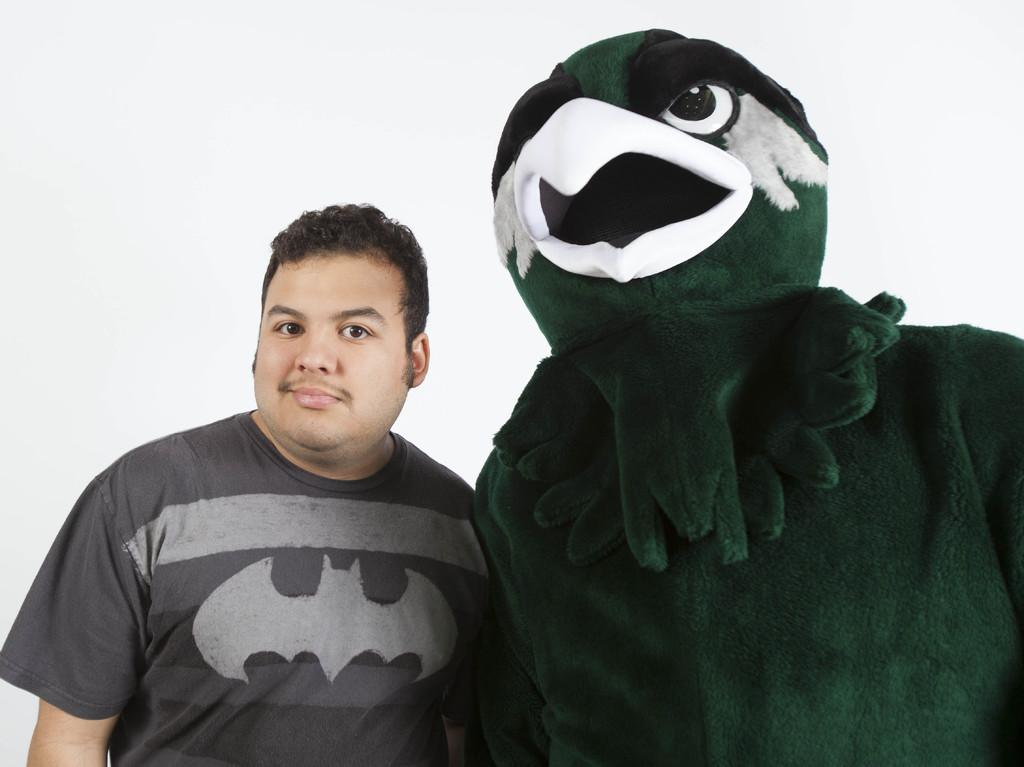What is the person on the right side of the image wearing? The person on the right side is wearing a costume of a bird. Can you describe the other person in the image? There is another person standing on the left side of the image. What is the position of the person on the right side of the image? The person on the right side is standing. What type of butter is being used to write a message on the costume? There is no butter or writing present in the image; the person is simply wearing a bird costume. 